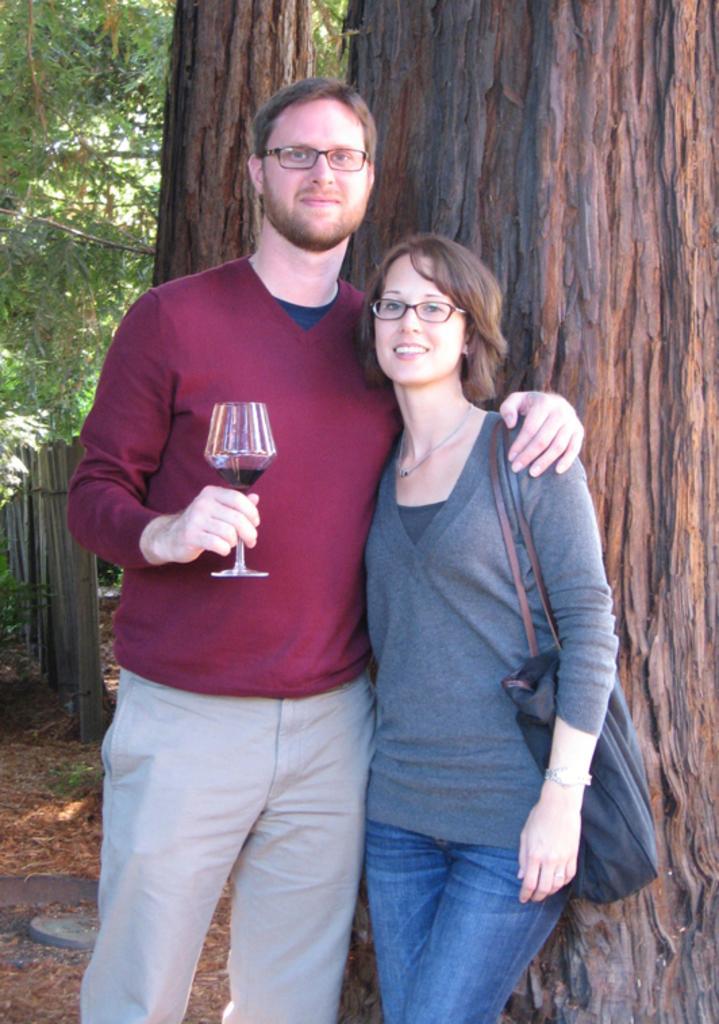Describe this image in one or two sentences. In this image i can see a man and a woman are standing. The man is holding a wine glass and woman is carrying a bag. I can also see there is a tree behind these people. 